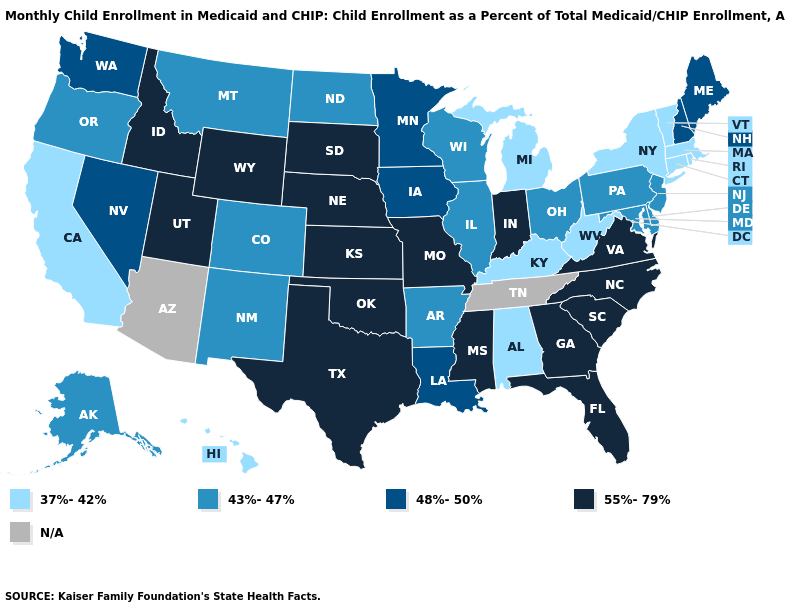What is the value of Arizona?
Quick response, please. N/A. What is the value of Alaska?
Concise answer only. 43%-47%. What is the value of Connecticut?
Short answer required. 37%-42%. Name the states that have a value in the range 55%-79%?
Short answer required. Florida, Georgia, Idaho, Indiana, Kansas, Mississippi, Missouri, Nebraska, North Carolina, Oklahoma, South Carolina, South Dakota, Texas, Utah, Virginia, Wyoming. Name the states that have a value in the range 55%-79%?
Quick response, please. Florida, Georgia, Idaho, Indiana, Kansas, Mississippi, Missouri, Nebraska, North Carolina, Oklahoma, South Carolina, South Dakota, Texas, Utah, Virginia, Wyoming. Among the states that border Utah , does New Mexico have the highest value?
Give a very brief answer. No. How many symbols are there in the legend?
Short answer required. 5. Name the states that have a value in the range N/A?
Quick response, please. Arizona, Tennessee. Name the states that have a value in the range 48%-50%?
Write a very short answer. Iowa, Louisiana, Maine, Minnesota, Nevada, New Hampshire, Washington. What is the value of Louisiana?
Be succinct. 48%-50%. Name the states that have a value in the range 37%-42%?
Give a very brief answer. Alabama, California, Connecticut, Hawaii, Kentucky, Massachusetts, Michigan, New York, Rhode Island, Vermont, West Virginia. What is the highest value in states that border South Carolina?
Answer briefly. 55%-79%. Among the states that border New Jersey , does Pennsylvania have the highest value?
Short answer required. Yes. What is the value of Maryland?
Concise answer only. 43%-47%. Is the legend a continuous bar?
Concise answer only. No. 